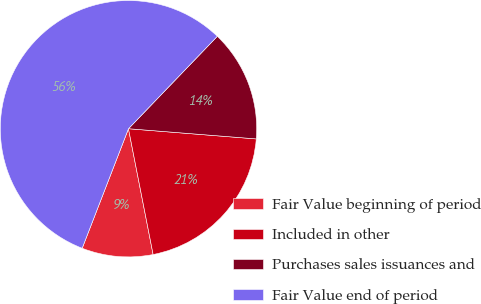Convert chart to OTSL. <chart><loc_0><loc_0><loc_500><loc_500><pie_chart><fcel>Fair Value beginning of period<fcel>Included in other<fcel>Purchases sales issuances and<fcel>Fair Value end of period<nl><fcel>8.96%<fcel>20.65%<fcel>14.08%<fcel>56.3%<nl></chart> 